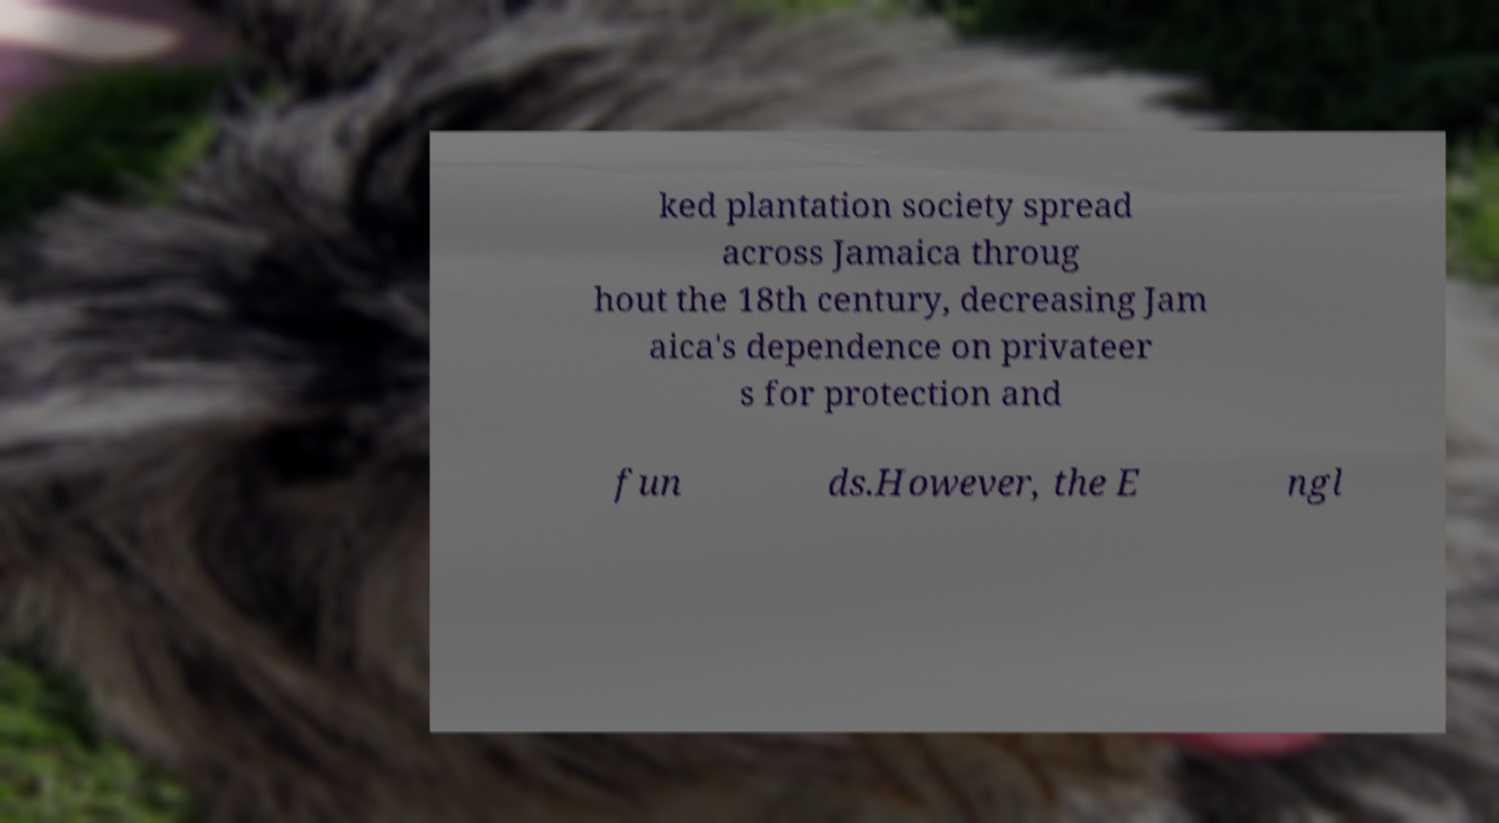Please identify and transcribe the text found in this image. ked plantation society spread across Jamaica throug hout the 18th century, decreasing Jam aica's dependence on privateer s for protection and fun ds.However, the E ngl 